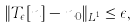Convert formula to latex. <formula><loc_0><loc_0><loc_500><loc_500>\| T _ { \epsilon } [ n ] - n _ { 0 } \| _ { L ^ { 1 } } \leq \epsilon ,</formula> 